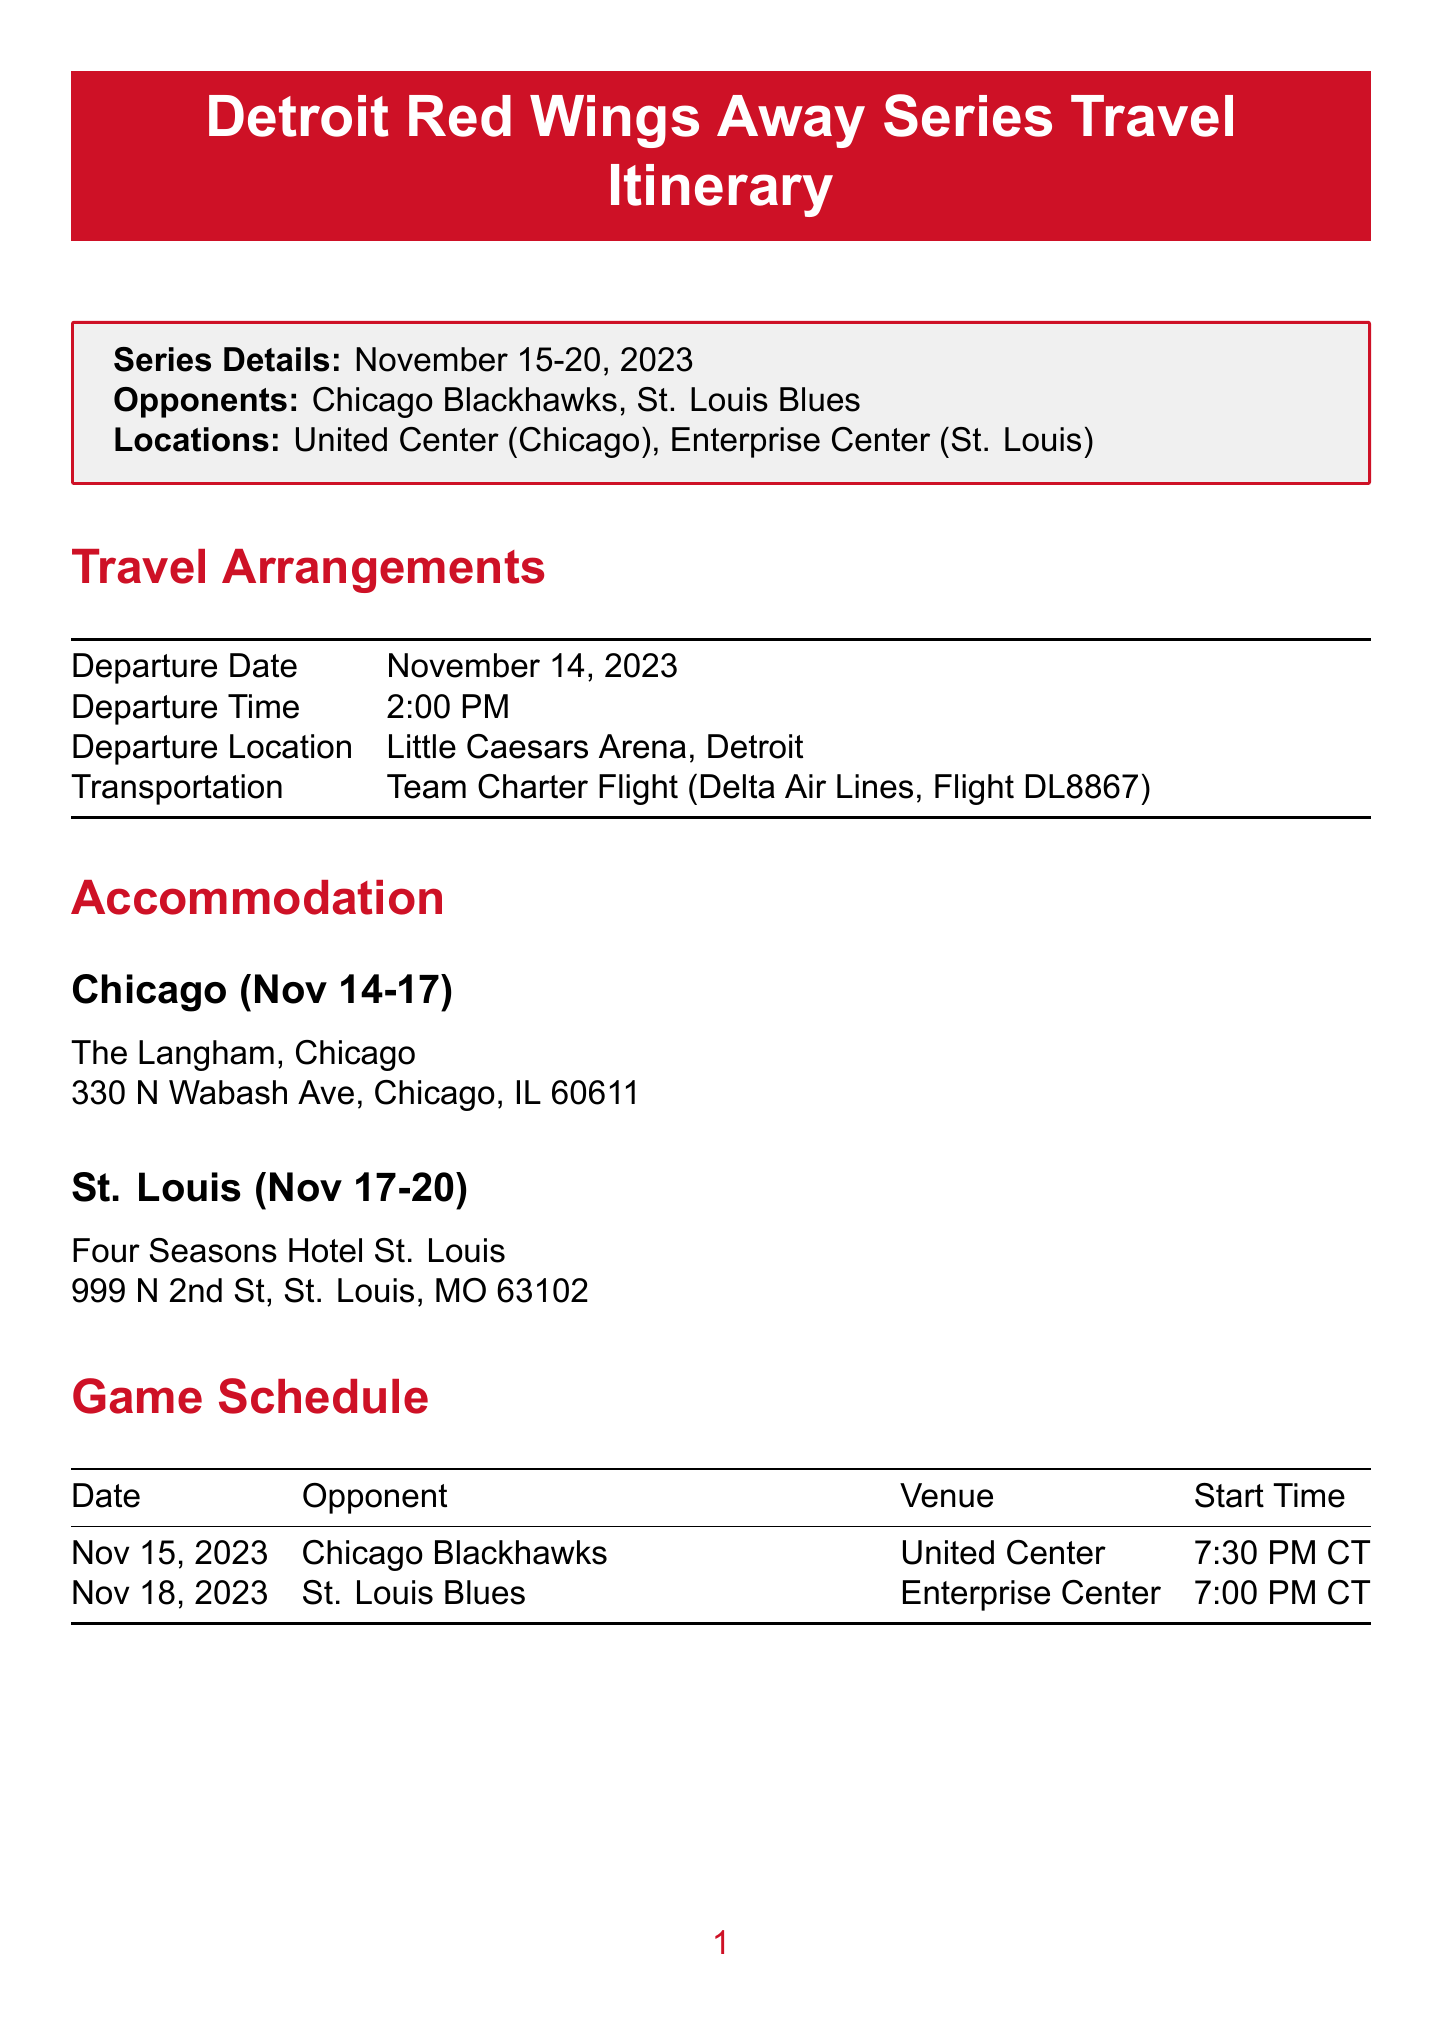What are the series dates? The series dates are mentioned at the beginning of the document, which is November 15-20, 2023.
Answer: November 15-20, 2023 What is the departure time? The document specifies the departure time in the travel arrangements section, which is at 2:00 PM.
Answer: 2:00 PM Where is the team staying in Chicago? The accommodation section provides the hotel name for Chicago, which is The Langham, Chicago.
Answer: The Langham, Chicago What is the opponent for the game on November 18, 2023? The game schedule lists the opponents, revealing that the opponent on this date is St. Louis Blues.
Answer: St. Louis Blues Who is responsible for equipment? The equipment notes section identifies the responsible person as John Anderson, Equipment Manager.
Answer: John Anderson Why is the team arriving on a charter flight? The travel arrangements indicate that a team charter flight is the method chosen for travel, which suggests the need for coordinated team operations.
Answer: Team Charter Flight What time is the curfew on non-game nights? The additional notes mention the curfew time for non-game nights, which is 11:00 PM.
Answer: 11:00 PM Where is the team practicing on November 16, 2023? The practice schedule section states that the practice on this date will occur at Fifth Third Arena, Chicago.
Answer: Fifth Third Arena, Chicago What is the estimated arrival time back in Detroit? The return travel section provides the estimated arrival time as 1:30 PM.
Answer: 1:30 PM 